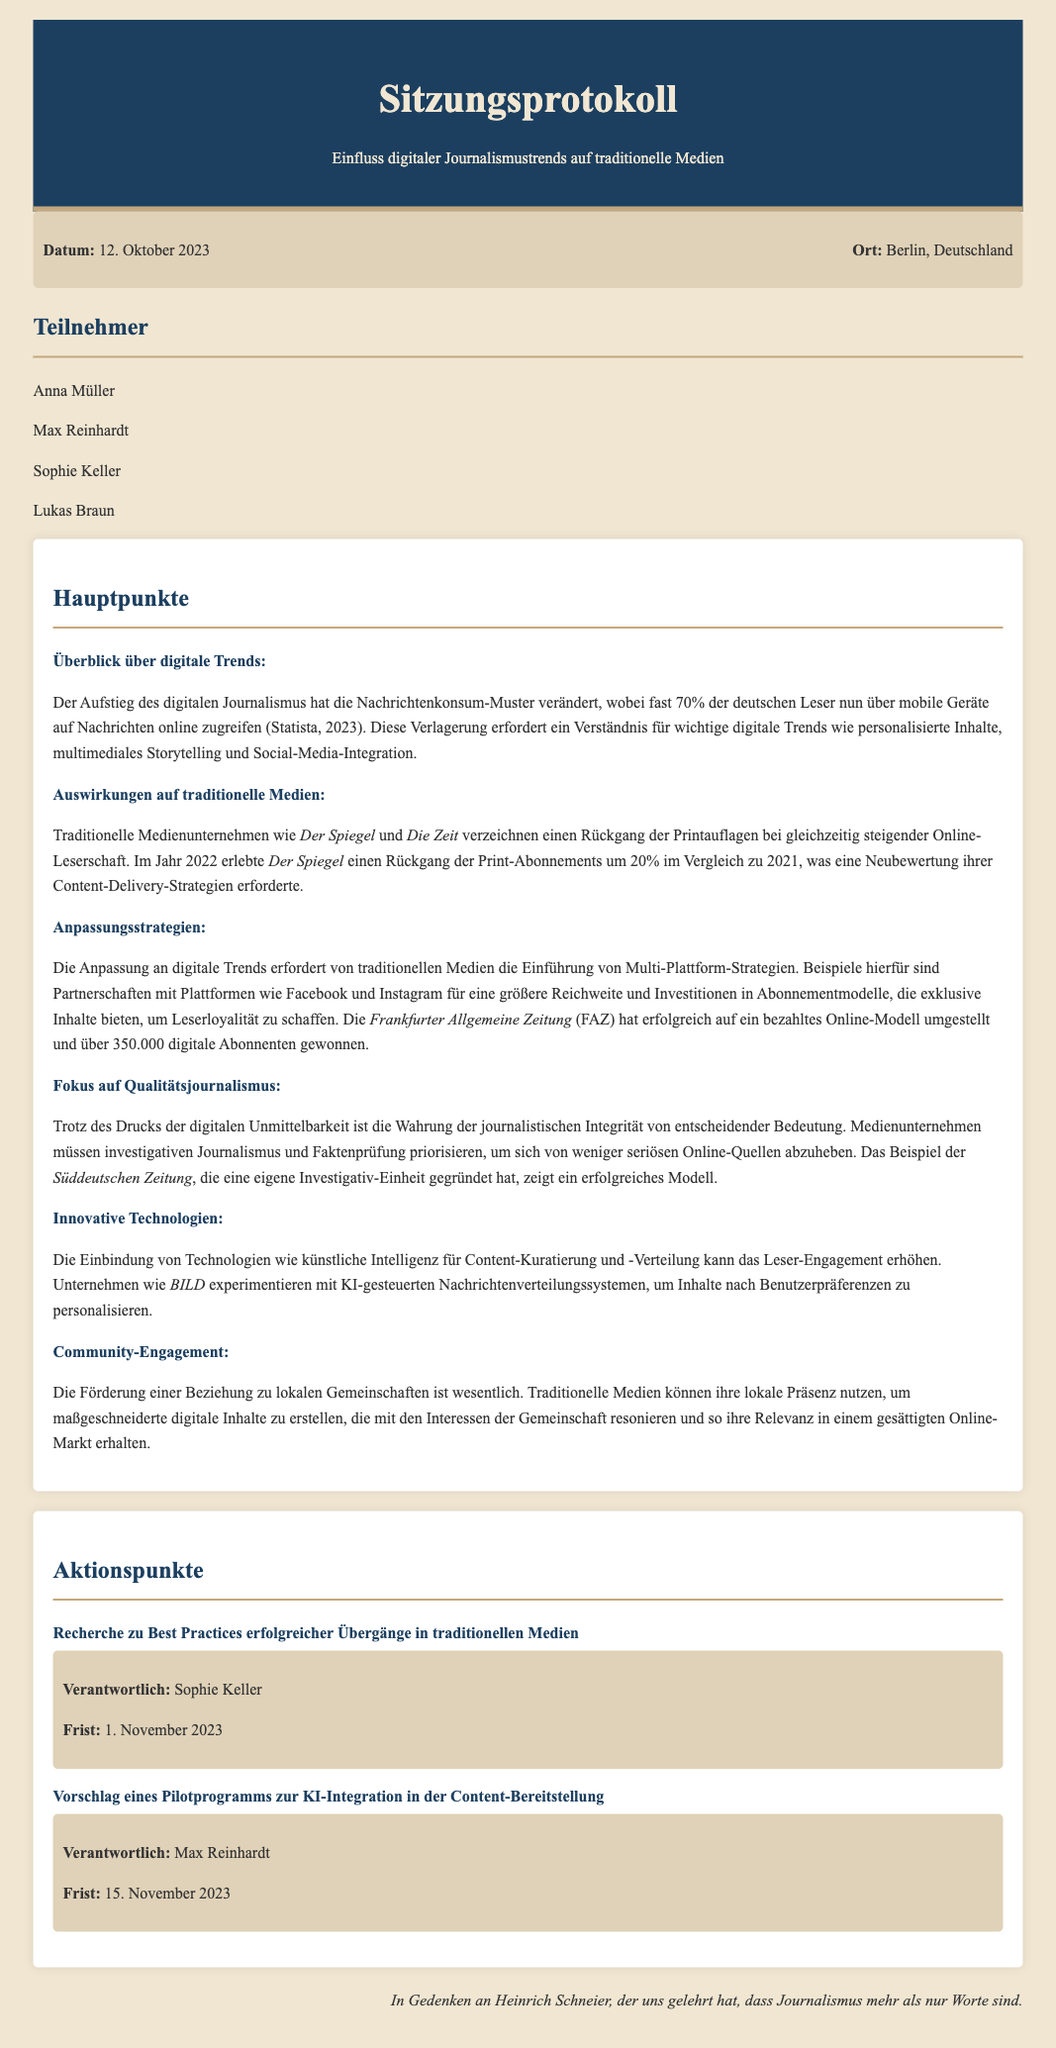Was ist das Datum des Treffens? Das Datum des Treffens ist im oberen Bereich des Dokuments angegeben.
Answer: 12. Oktober 2023 Wo fand das Treffen statt? Der Ort des Treffens ist ebenfalls im oberen Bereich des Dokuments vermerkt.
Answer: Berlin, Deutschland Wer war für die Recherche zu Best Practices verantwortlich? Die Verantwortlichkeit für die Recherche zu Best Practices steht in der Liste der Aktionspunkte.
Answer: Sophie Keller Was war der Rückgang der Print-Abonnements von Der Spiegel im Jahr 2022? Diese Information ist im Abschnitt über die Auswirkungen auf traditionelle Medien zu finden.
Answer: 20% Welche Strategie wird für Qualitätsjournalismus hervorgehoben? Die Hauptpunkte besprechen den Fokus auf Qualitätsjournalismus und die damit verbundenen Strategien.
Answer: Investigativen Journalismus und Faktenprüfung Welches Unternehmen hat über 350.000 digitale Abonnenten gewonnen? Dies ist eine wichtige Information im Abschnitt über Anpassungsstrategien im Dokument.
Answer: Frankfurter Allgemeine Zeitung Was wird als essentielle Möglichkeit zur Erhöhung des Leser-Engagements erwähnt? Innovationspunkt im Dokument spricht über die Rolle der Technologien in der Content-Verteilung.
Answer: Künstliche Intelligenz Wie viele Teilnehmer waren bei dem Treffen? Die Anzahl der Teilnehmer kann aus der Liste im entsprechenden Abschnitt im Dokument ermittelt werden.
Answer: Vier 